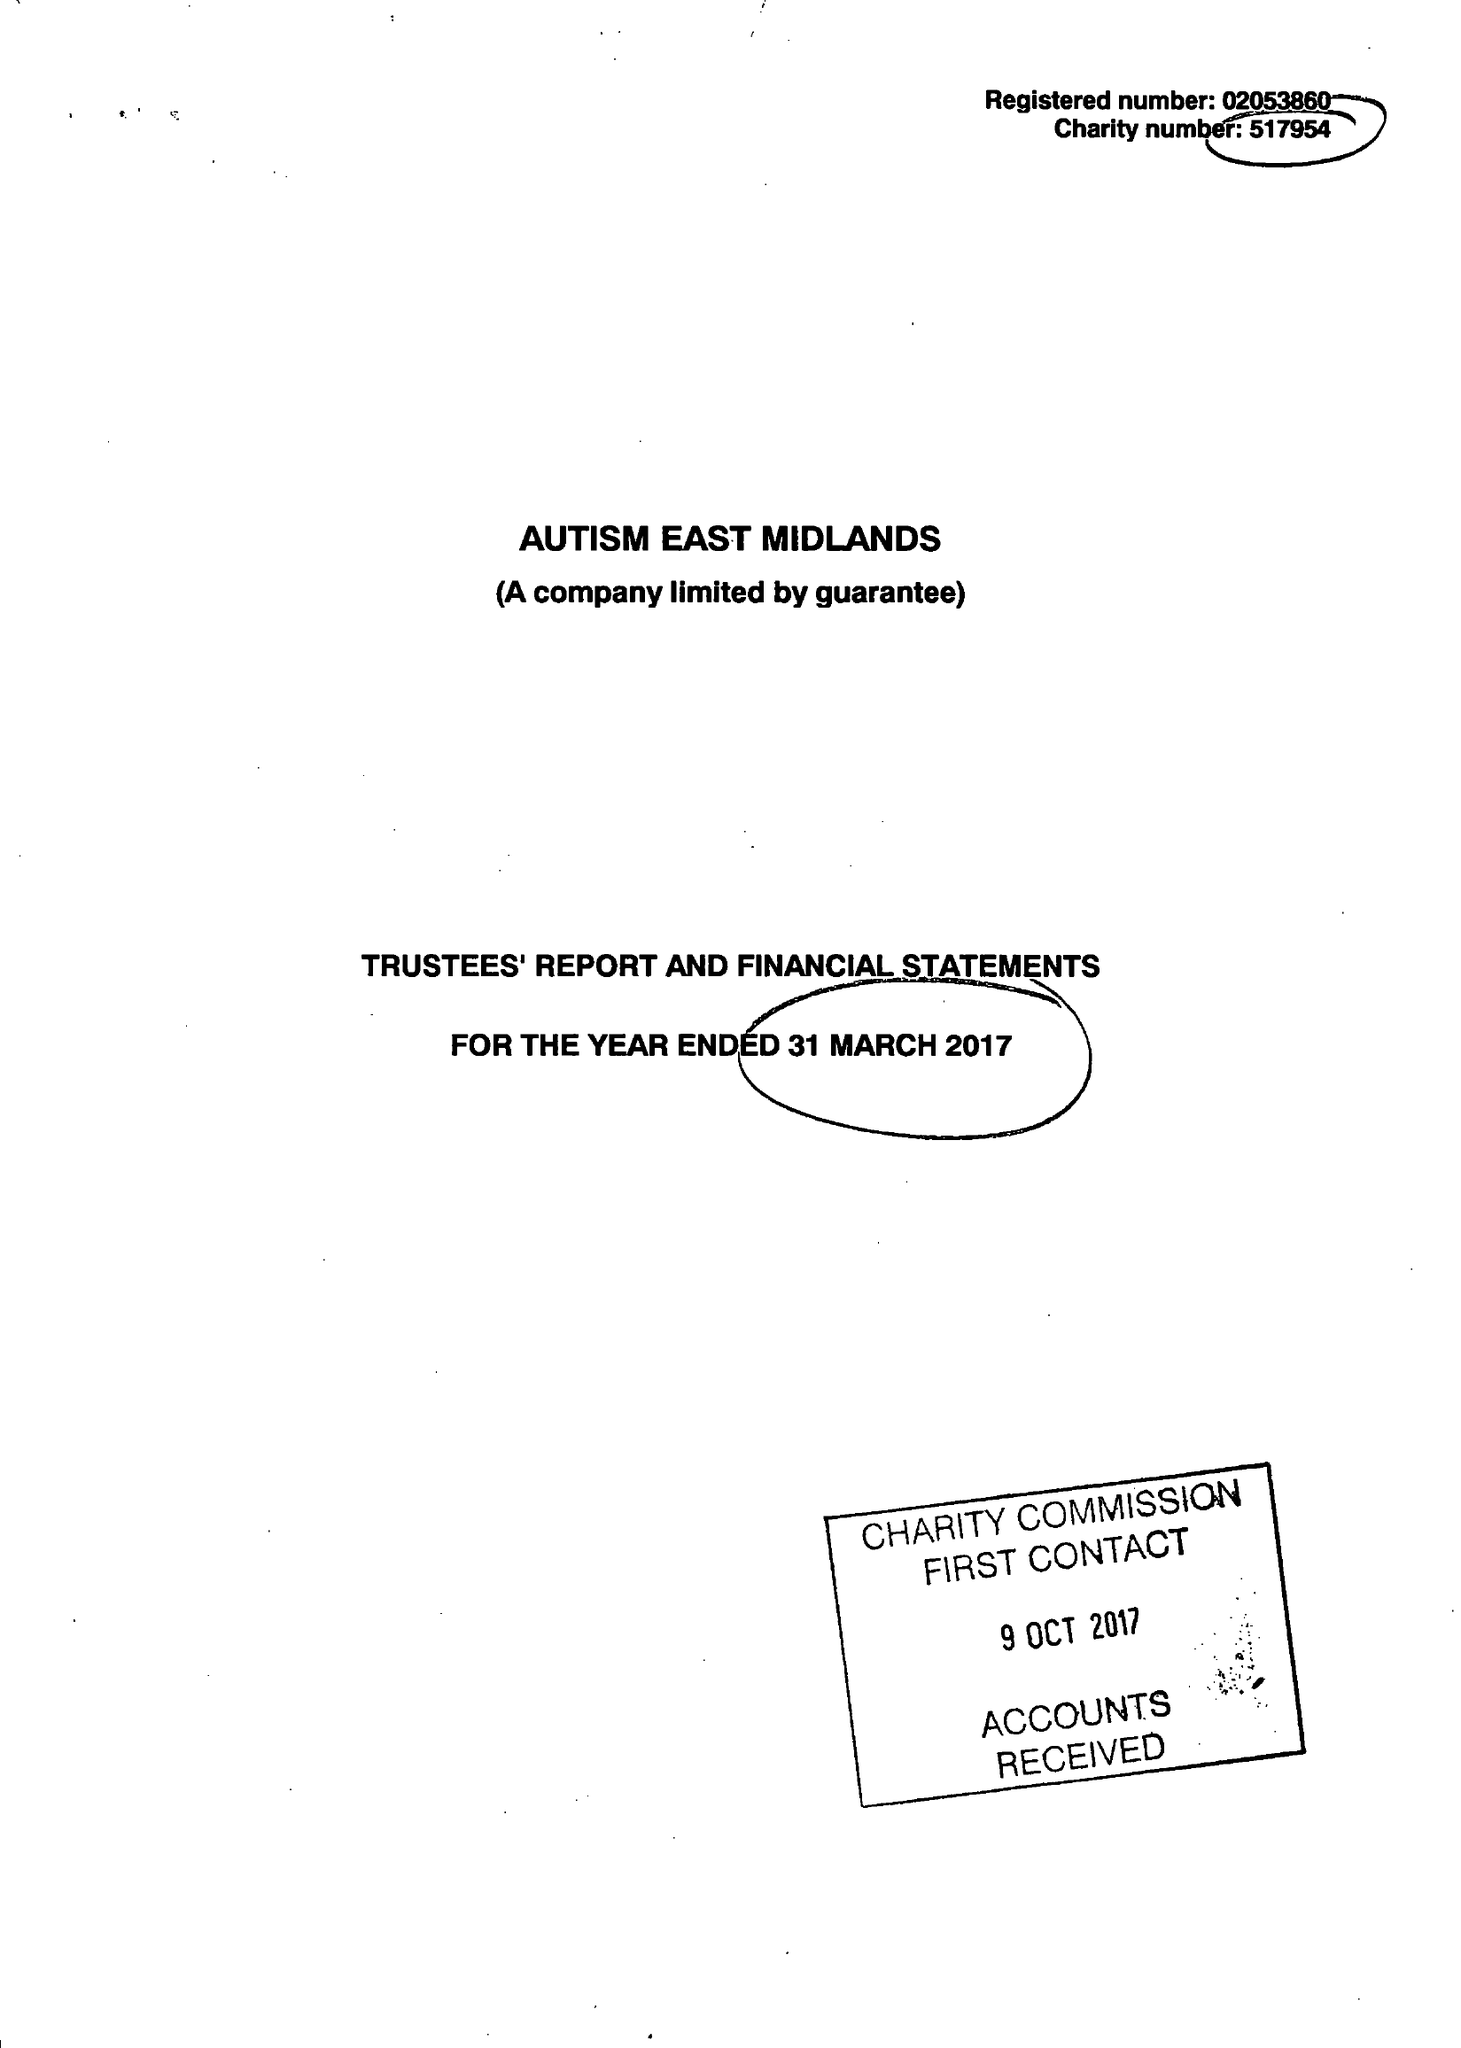What is the value for the charity_name?
Answer the question using a single word or phrase. Autism East Midlands 